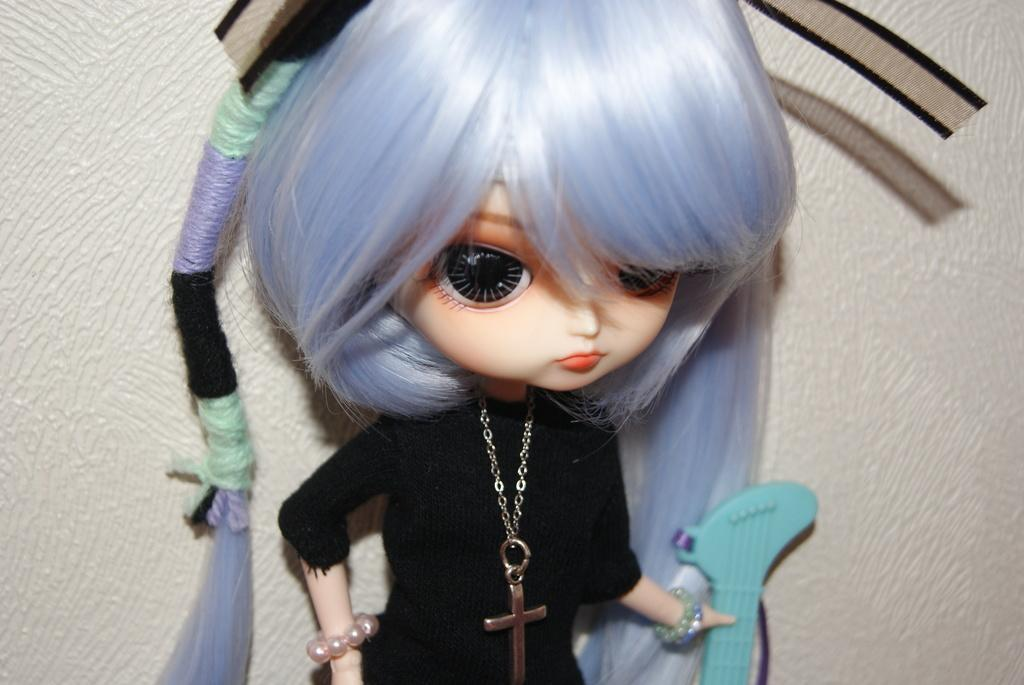What is the main subject in the image? There is a doll in the image. What is the doll wearing? The doll is wearing clothes and a bracelet. What can be seen in the image besides the doll? There is a chain and a cross mark in the image. What is the doll holding in its hand? The doll is holding an object in its hand. What type of jeans is the doll wearing in the image? The doll is not wearing jeans in the image; it is wearing clothes, but the specific type of clothing is not mentioned. Can you tell me how the doll is using its throat in the image? The doll does not have a throat, as it is an inanimate object, and therefore cannot use it in any way. 